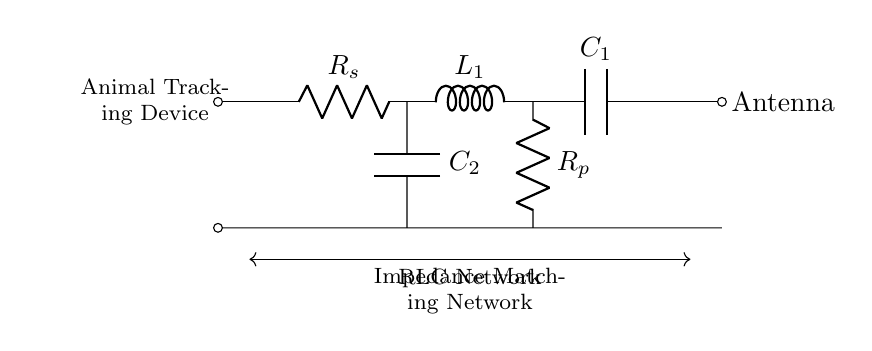What does R_s represent in the circuit? R_s represents the source resistance in the impedance matching network. It is crucial for optimizing the power transfer to the antenna.
Answer: source resistance What is the purpose of the capacitors in this circuit? The capacitors (C1 and C2) in the circuit are used for tuning the impedance to match the antenna's characteristics, which helps in maximizing signal efficiency.
Answer: tuning impedance How many components are in the RLC network? The RLC network consists of three different components: one resistor, one inductor, and two capacitors.
Answer: four components What is connected to the right side of the circuit? The right side of the circuit is connected to the antenna, which is the intended load for the RLC network.
Answer: Antenna Which component provides inductance in this circuit? The component providing inductance in this circuit is L1, which influences the reactive component of the impedance.
Answer: L1 What is the role of R_p in this circuit? R_p is the load resistance that plays a key role in defining the overall impedance of the antenna system in conjunction with L1 and C1.
Answer: load resistance Why is an impedance matching network used? An impedance matching network is used to ensure maximum power transfer from the tracking device to the antenna by minimizing reflections.
Answer: maximum power transfer 